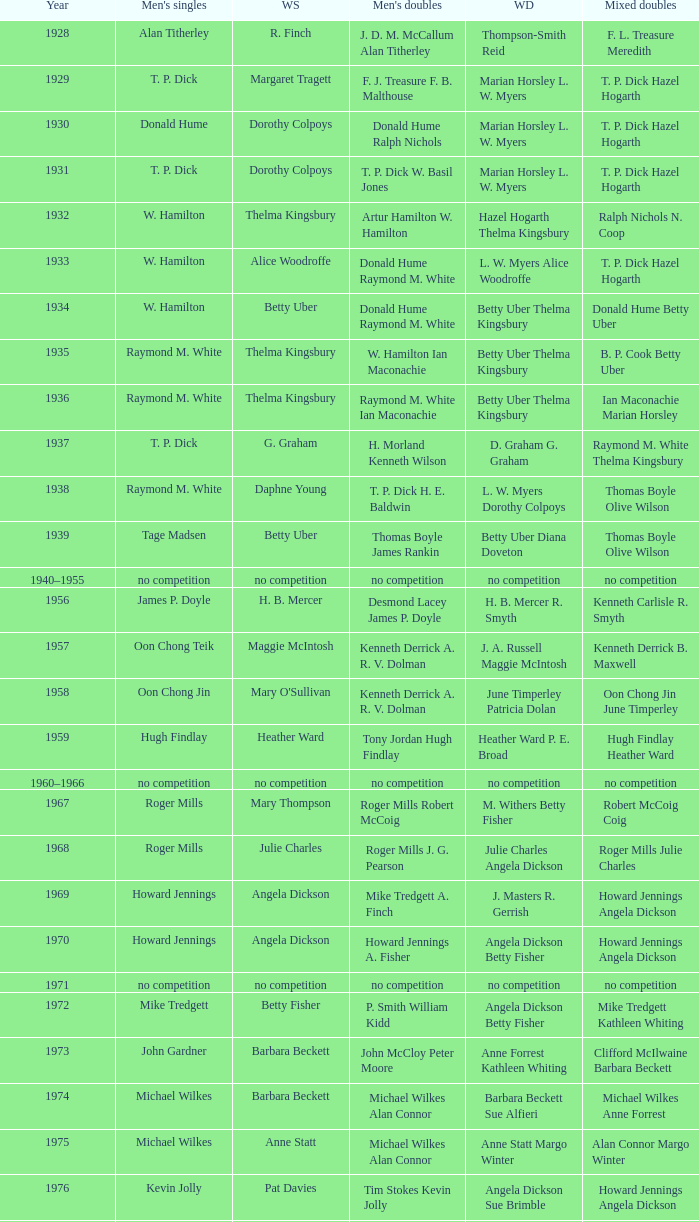Who won the Men's singles in the year that Ian Maconachie Marian Horsley won the Mixed doubles? Raymond M. White. 